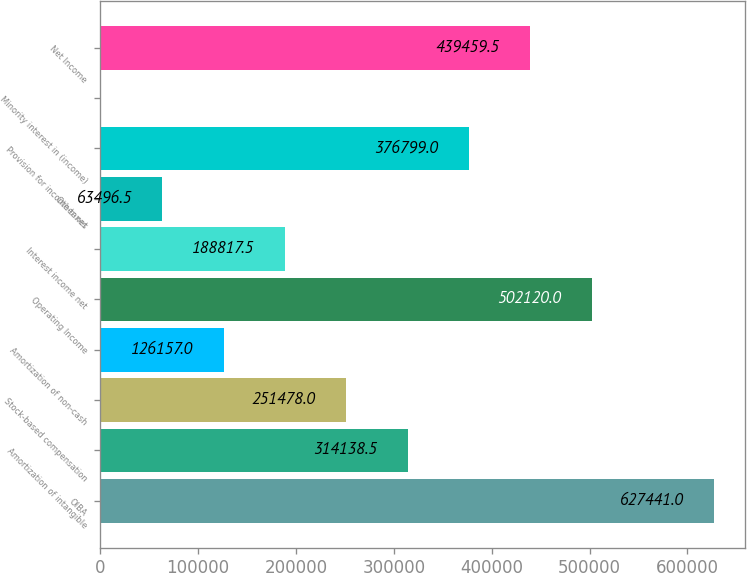Convert chart to OTSL. <chart><loc_0><loc_0><loc_500><loc_500><bar_chart><fcel>OIBA<fcel>Amortization of intangible<fcel>Stock-based compensation<fcel>Amortization of non-cash<fcel>Operating Income<fcel>Interest income net<fcel>Other net<fcel>Provision for income taxes<fcel>Minority interest in (income)<fcel>Net Income<nl><fcel>627441<fcel>314138<fcel>251478<fcel>126157<fcel>502120<fcel>188818<fcel>63496.5<fcel>376799<fcel>836<fcel>439460<nl></chart> 